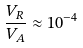Convert formula to latex. <formula><loc_0><loc_0><loc_500><loc_500>\frac { V _ { R } } { V _ { A } } \approx 1 0 ^ { - 4 }</formula> 